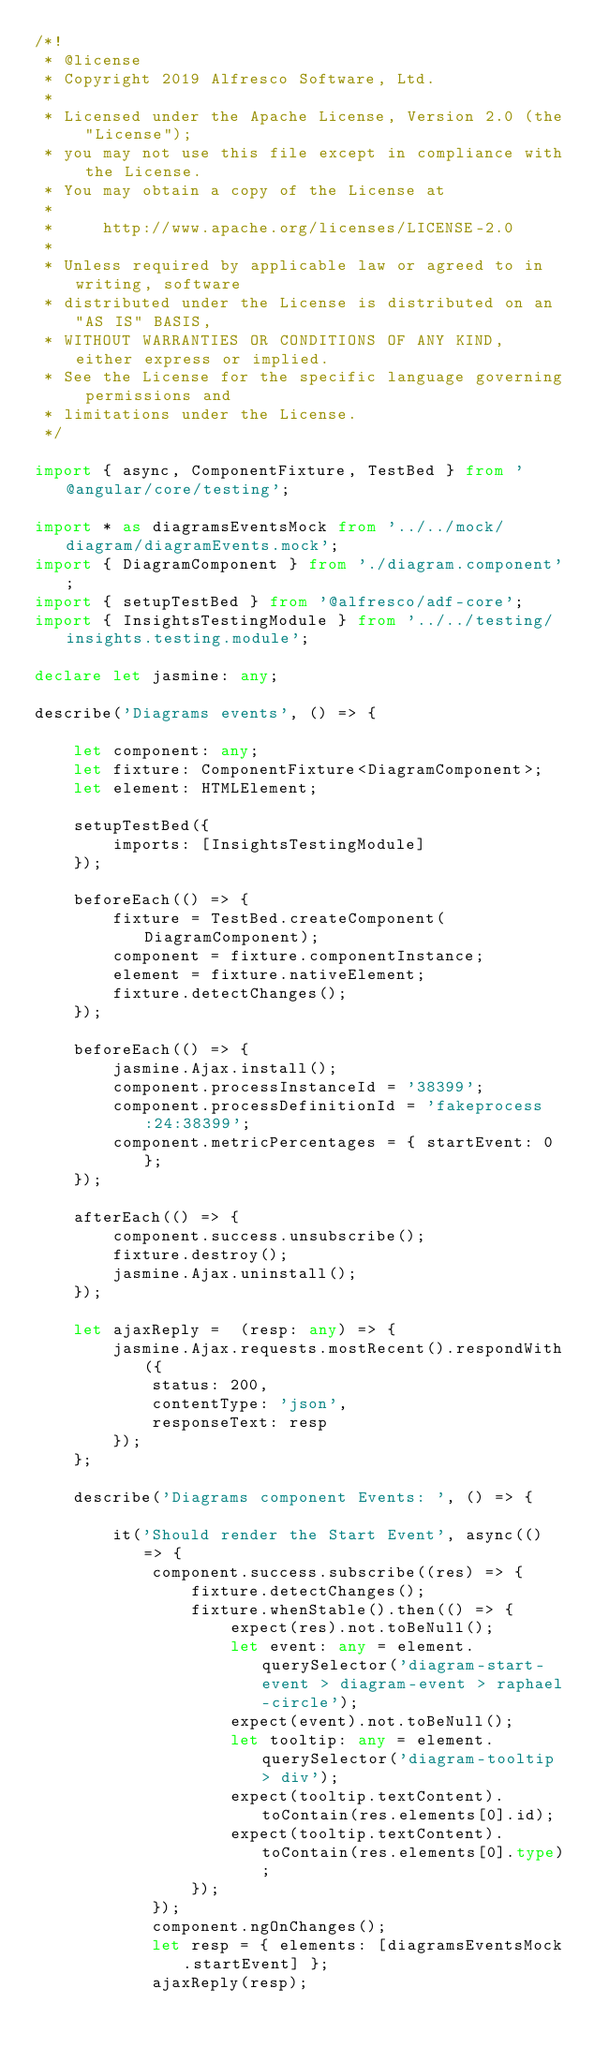<code> <loc_0><loc_0><loc_500><loc_500><_TypeScript_>/*!
 * @license
 * Copyright 2019 Alfresco Software, Ltd.
 *
 * Licensed under the Apache License, Version 2.0 (the "License");
 * you may not use this file except in compliance with the License.
 * You may obtain a copy of the License at
 *
 *     http://www.apache.org/licenses/LICENSE-2.0
 *
 * Unless required by applicable law or agreed to in writing, software
 * distributed under the License is distributed on an "AS IS" BASIS,
 * WITHOUT WARRANTIES OR CONDITIONS OF ANY KIND, either express or implied.
 * See the License for the specific language governing permissions and
 * limitations under the License.
 */

import { async, ComponentFixture, TestBed } from '@angular/core/testing';

import * as diagramsEventsMock from '../../mock/diagram/diagramEvents.mock';
import { DiagramComponent } from './diagram.component';
import { setupTestBed } from '@alfresco/adf-core';
import { InsightsTestingModule } from '../../testing/insights.testing.module';

declare let jasmine: any;

describe('Diagrams events', () => {

    let component: any;
    let fixture: ComponentFixture<DiagramComponent>;
    let element: HTMLElement;

    setupTestBed({
        imports: [InsightsTestingModule]
    });

    beforeEach(() => {
        fixture = TestBed.createComponent(DiagramComponent);
        component = fixture.componentInstance;
        element = fixture.nativeElement;
        fixture.detectChanges();
    });

    beforeEach(() => {
        jasmine.Ajax.install();
        component.processInstanceId = '38399';
        component.processDefinitionId = 'fakeprocess:24:38399';
        component.metricPercentages = { startEvent: 0 };
    });

    afterEach(() => {
        component.success.unsubscribe();
        fixture.destroy();
        jasmine.Ajax.uninstall();
    });

    let ajaxReply =  (resp: any) => {
        jasmine.Ajax.requests.mostRecent().respondWith({
            status: 200,
            contentType: 'json',
            responseText: resp
        });
    };

    describe('Diagrams component Events: ', () => {

        it('Should render the Start Event', async(() => {
            component.success.subscribe((res) => {
                fixture.detectChanges();
                fixture.whenStable().then(() => {
                    expect(res).not.toBeNull();
                    let event: any = element.querySelector('diagram-start-event > diagram-event > raphael-circle');
                    expect(event).not.toBeNull();
                    let tooltip: any = element.querySelector('diagram-tooltip > div');
                    expect(tooltip.textContent).toContain(res.elements[0].id);
                    expect(tooltip.textContent).toContain(res.elements[0].type);
                });
            });
            component.ngOnChanges();
            let resp = { elements: [diagramsEventsMock.startEvent] };
            ajaxReply(resp);</code> 